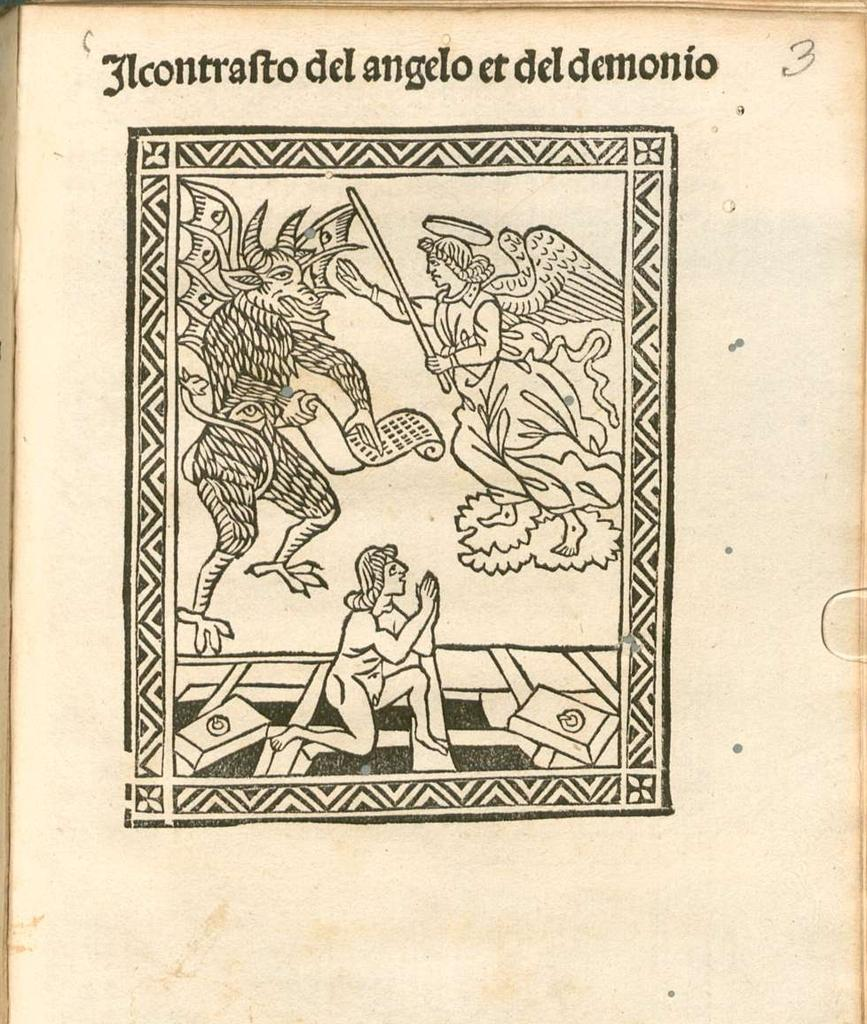What object is the main focus of the image? There is a box in the image. What is inside the box? The box contains art. Is there any text visible in the image? Yes, there is text present in the image. What type of polish is being applied to the houses in the image? There are no houses or polish present in the image; it features a box containing art and text. 